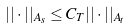<formula> <loc_0><loc_0><loc_500><loc_500>| | \cdot | | _ { A _ { s } } \leq C _ { T } | | \cdot | | _ { A _ { t } }</formula> 